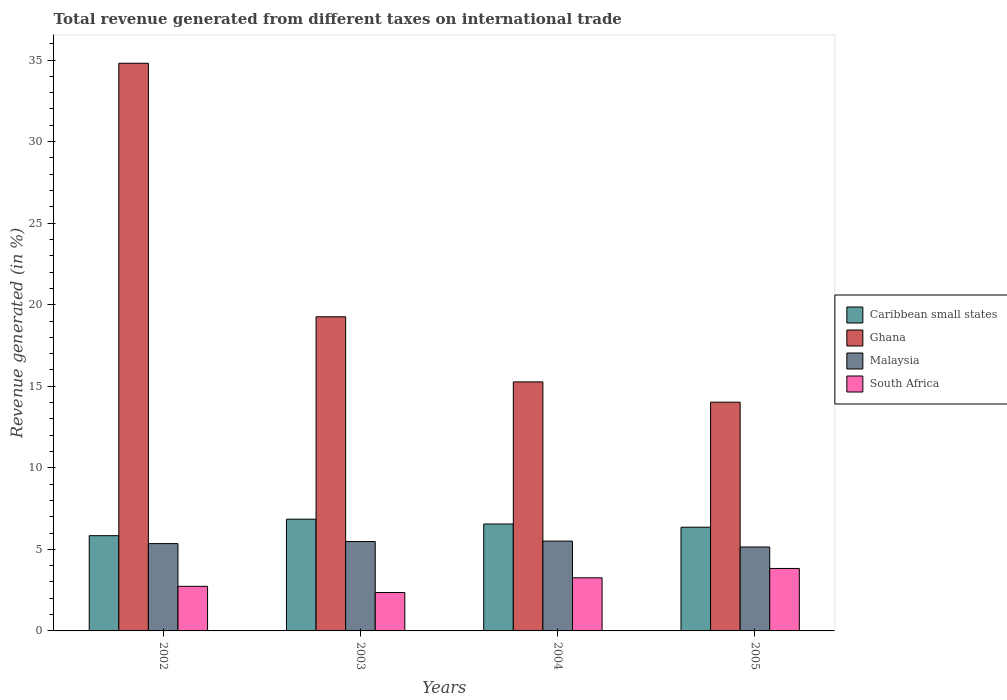Are the number of bars per tick equal to the number of legend labels?
Ensure brevity in your answer.  Yes. How many bars are there on the 1st tick from the right?
Offer a terse response. 4. What is the total revenue generated in Caribbean small states in 2003?
Give a very brief answer. 6.85. Across all years, what is the maximum total revenue generated in Caribbean small states?
Ensure brevity in your answer.  6.85. Across all years, what is the minimum total revenue generated in South Africa?
Offer a terse response. 2.36. In which year was the total revenue generated in South Africa minimum?
Offer a terse response. 2003. What is the total total revenue generated in Ghana in the graph?
Your answer should be very brief. 83.35. What is the difference between the total revenue generated in South Africa in 2002 and that in 2005?
Keep it short and to the point. -1.1. What is the difference between the total revenue generated in South Africa in 2005 and the total revenue generated in Malaysia in 2004?
Your answer should be compact. -1.68. What is the average total revenue generated in Ghana per year?
Give a very brief answer. 20.84. In the year 2005, what is the difference between the total revenue generated in Malaysia and total revenue generated in Ghana?
Your answer should be very brief. -8.88. What is the ratio of the total revenue generated in Ghana in 2004 to that in 2005?
Ensure brevity in your answer.  1.09. Is the total revenue generated in South Africa in 2003 less than that in 2004?
Keep it short and to the point. Yes. Is the difference between the total revenue generated in Malaysia in 2002 and 2003 greater than the difference between the total revenue generated in Ghana in 2002 and 2003?
Ensure brevity in your answer.  No. What is the difference between the highest and the second highest total revenue generated in South Africa?
Your response must be concise. 0.57. What is the difference between the highest and the lowest total revenue generated in Malaysia?
Give a very brief answer. 0.36. What does the 4th bar from the left in 2005 represents?
Your response must be concise. South Africa. What does the 3rd bar from the right in 2004 represents?
Ensure brevity in your answer.  Ghana. Is it the case that in every year, the sum of the total revenue generated in South Africa and total revenue generated in Caribbean small states is greater than the total revenue generated in Ghana?
Make the answer very short. No. What is the difference between two consecutive major ticks on the Y-axis?
Ensure brevity in your answer.  5. Does the graph contain any zero values?
Provide a succinct answer. No. Does the graph contain grids?
Provide a short and direct response. No. What is the title of the graph?
Your answer should be very brief. Total revenue generated from different taxes on international trade. What is the label or title of the X-axis?
Your answer should be very brief. Years. What is the label or title of the Y-axis?
Keep it short and to the point. Revenue generated (in %). What is the Revenue generated (in %) in Caribbean small states in 2002?
Provide a short and direct response. 5.84. What is the Revenue generated (in %) of Ghana in 2002?
Give a very brief answer. 34.8. What is the Revenue generated (in %) in Malaysia in 2002?
Make the answer very short. 5.35. What is the Revenue generated (in %) of South Africa in 2002?
Your answer should be compact. 2.73. What is the Revenue generated (in %) in Caribbean small states in 2003?
Your answer should be very brief. 6.85. What is the Revenue generated (in %) in Ghana in 2003?
Give a very brief answer. 19.26. What is the Revenue generated (in %) of Malaysia in 2003?
Provide a short and direct response. 5.48. What is the Revenue generated (in %) in South Africa in 2003?
Your response must be concise. 2.36. What is the Revenue generated (in %) of Caribbean small states in 2004?
Keep it short and to the point. 6.56. What is the Revenue generated (in %) in Ghana in 2004?
Give a very brief answer. 15.27. What is the Revenue generated (in %) in Malaysia in 2004?
Your answer should be very brief. 5.51. What is the Revenue generated (in %) in South Africa in 2004?
Your answer should be compact. 3.26. What is the Revenue generated (in %) in Caribbean small states in 2005?
Offer a terse response. 6.36. What is the Revenue generated (in %) in Ghana in 2005?
Provide a succinct answer. 14.02. What is the Revenue generated (in %) in Malaysia in 2005?
Keep it short and to the point. 5.15. What is the Revenue generated (in %) of South Africa in 2005?
Provide a succinct answer. 3.83. Across all years, what is the maximum Revenue generated (in %) in Caribbean small states?
Offer a very short reply. 6.85. Across all years, what is the maximum Revenue generated (in %) of Ghana?
Offer a terse response. 34.8. Across all years, what is the maximum Revenue generated (in %) in Malaysia?
Ensure brevity in your answer.  5.51. Across all years, what is the maximum Revenue generated (in %) in South Africa?
Give a very brief answer. 3.83. Across all years, what is the minimum Revenue generated (in %) in Caribbean small states?
Ensure brevity in your answer.  5.84. Across all years, what is the minimum Revenue generated (in %) of Ghana?
Offer a terse response. 14.02. Across all years, what is the minimum Revenue generated (in %) of Malaysia?
Your answer should be compact. 5.15. Across all years, what is the minimum Revenue generated (in %) in South Africa?
Ensure brevity in your answer.  2.36. What is the total Revenue generated (in %) in Caribbean small states in the graph?
Your answer should be compact. 25.6. What is the total Revenue generated (in %) in Ghana in the graph?
Your answer should be very brief. 83.35. What is the total Revenue generated (in %) of Malaysia in the graph?
Ensure brevity in your answer.  21.49. What is the total Revenue generated (in %) of South Africa in the graph?
Keep it short and to the point. 12.18. What is the difference between the Revenue generated (in %) of Caribbean small states in 2002 and that in 2003?
Give a very brief answer. -1.01. What is the difference between the Revenue generated (in %) of Ghana in 2002 and that in 2003?
Keep it short and to the point. 15.54. What is the difference between the Revenue generated (in %) of Malaysia in 2002 and that in 2003?
Keep it short and to the point. -0.13. What is the difference between the Revenue generated (in %) of South Africa in 2002 and that in 2003?
Your answer should be very brief. 0.38. What is the difference between the Revenue generated (in %) of Caribbean small states in 2002 and that in 2004?
Offer a terse response. -0.72. What is the difference between the Revenue generated (in %) in Ghana in 2002 and that in 2004?
Provide a short and direct response. 19.54. What is the difference between the Revenue generated (in %) of Malaysia in 2002 and that in 2004?
Offer a terse response. -0.15. What is the difference between the Revenue generated (in %) of South Africa in 2002 and that in 2004?
Your answer should be compact. -0.52. What is the difference between the Revenue generated (in %) in Caribbean small states in 2002 and that in 2005?
Give a very brief answer. -0.52. What is the difference between the Revenue generated (in %) of Ghana in 2002 and that in 2005?
Your response must be concise. 20.78. What is the difference between the Revenue generated (in %) of Malaysia in 2002 and that in 2005?
Offer a very short reply. 0.21. What is the difference between the Revenue generated (in %) of South Africa in 2002 and that in 2005?
Your response must be concise. -1.1. What is the difference between the Revenue generated (in %) of Caribbean small states in 2003 and that in 2004?
Give a very brief answer. 0.3. What is the difference between the Revenue generated (in %) of Ghana in 2003 and that in 2004?
Provide a short and direct response. 3.99. What is the difference between the Revenue generated (in %) of Malaysia in 2003 and that in 2004?
Your response must be concise. -0.03. What is the difference between the Revenue generated (in %) in South Africa in 2003 and that in 2004?
Your answer should be very brief. -0.9. What is the difference between the Revenue generated (in %) in Caribbean small states in 2003 and that in 2005?
Your response must be concise. 0.49. What is the difference between the Revenue generated (in %) in Ghana in 2003 and that in 2005?
Offer a terse response. 5.24. What is the difference between the Revenue generated (in %) of Malaysia in 2003 and that in 2005?
Ensure brevity in your answer.  0.33. What is the difference between the Revenue generated (in %) in South Africa in 2003 and that in 2005?
Provide a short and direct response. -1.47. What is the difference between the Revenue generated (in %) of Caribbean small states in 2004 and that in 2005?
Give a very brief answer. 0.2. What is the difference between the Revenue generated (in %) in Ghana in 2004 and that in 2005?
Provide a short and direct response. 1.24. What is the difference between the Revenue generated (in %) of Malaysia in 2004 and that in 2005?
Offer a very short reply. 0.36. What is the difference between the Revenue generated (in %) in South Africa in 2004 and that in 2005?
Ensure brevity in your answer.  -0.57. What is the difference between the Revenue generated (in %) of Caribbean small states in 2002 and the Revenue generated (in %) of Ghana in 2003?
Give a very brief answer. -13.42. What is the difference between the Revenue generated (in %) of Caribbean small states in 2002 and the Revenue generated (in %) of Malaysia in 2003?
Give a very brief answer. 0.36. What is the difference between the Revenue generated (in %) in Caribbean small states in 2002 and the Revenue generated (in %) in South Africa in 2003?
Keep it short and to the point. 3.48. What is the difference between the Revenue generated (in %) of Ghana in 2002 and the Revenue generated (in %) of Malaysia in 2003?
Provide a succinct answer. 29.32. What is the difference between the Revenue generated (in %) in Ghana in 2002 and the Revenue generated (in %) in South Africa in 2003?
Offer a terse response. 32.45. What is the difference between the Revenue generated (in %) of Malaysia in 2002 and the Revenue generated (in %) of South Africa in 2003?
Provide a short and direct response. 3. What is the difference between the Revenue generated (in %) of Caribbean small states in 2002 and the Revenue generated (in %) of Ghana in 2004?
Offer a terse response. -9.43. What is the difference between the Revenue generated (in %) in Caribbean small states in 2002 and the Revenue generated (in %) in Malaysia in 2004?
Your response must be concise. 0.33. What is the difference between the Revenue generated (in %) of Caribbean small states in 2002 and the Revenue generated (in %) of South Africa in 2004?
Offer a terse response. 2.58. What is the difference between the Revenue generated (in %) in Ghana in 2002 and the Revenue generated (in %) in Malaysia in 2004?
Provide a succinct answer. 29.3. What is the difference between the Revenue generated (in %) of Ghana in 2002 and the Revenue generated (in %) of South Africa in 2004?
Provide a short and direct response. 31.55. What is the difference between the Revenue generated (in %) in Malaysia in 2002 and the Revenue generated (in %) in South Africa in 2004?
Offer a terse response. 2.1. What is the difference between the Revenue generated (in %) in Caribbean small states in 2002 and the Revenue generated (in %) in Ghana in 2005?
Your answer should be very brief. -8.19. What is the difference between the Revenue generated (in %) in Caribbean small states in 2002 and the Revenue generated (in %) in Malaysia in 2005?
Your answer should be very brief. 0.69. What is the difference between the Revenue generated (in %) of Caribbean small states in 2002 and the Revenue generated (in %) of South Africa in 2005?
Offer a very short reply. 2.01. What is the difference between the Revenue generated (in %) in Ghana in 2002 and the Revenue generated (in %) in Malaysia in 2005?
Your answer should be very brief. 29.66. What is the difference between the Revenue generated (in %) in Ghana in 2002 and the Revenue generated (in %) in South Africa in 2005?
Give a very brief answer. 30.97. What is the difference between the Revenue generated (in %) in Malaysia in 2002 and the Revenue generated (in %) in South Africa in 2005?
Provide a short and direct response. 1.52. What is the difference between the Revenue generated (in %) in Caribbean small states in 2003 and the Revenue generated (in %) in Ghana in 2004?
Make the answer very short. -8.42. What is the difference between the Revenue generated (in %) of Caribbean small states in 2003 and the Revenue generated (in %) of Malaysia in 2004?
Keep it short and to the point. 1.34. What is the difference between the Revenue generated (in %) of Caribbean small states in 2003 and the Revenue generated (in %) of South Africa in 2004?
Your answer should be very brief. 3.59. What is the difference between the Revenue generated (in %) in Ghana in 2003 and the Revenue generated (in %) in Malaysia in 2004?
Provide a succinct answer. 13.75. What is the difference between the Revenue generated (in %) in Ghana in 2003 and the Revenue generated (in %) in South Africa in 2004?
Keep it short and to the point. 16. What is the difference between the Revenue generated (in %) of Malaysia in 2003 and the Revenue generated (in %) of South Africa in 2004?
Give a very brief answer. 2.22. What is the difference between the Revenue generated (in %) in Caribbean small states in 2003 and the Revenue generated (in %) in Ghana in 2005?
Your answer should be compact. -7.17. What is the difference between the Revenue generated (in %) of Caribbean small states in 2003 and the Revenue generated (in %) of Malaysia in 2005?
Provide a succinct answer. 1.71. What is the difference between the Revenue generated (in %) in Caribbean small states in 2003 and the Revenue generated (in %) in South Africa in 2005?
Your response must be concise. 3.02. What is the difference between the Revenue generated (in %) in Ghana in 2003 and the Revenue generated (in %) in Malaysia in 2005?
Provide a succinct answer. 14.11. What is the difference between the Revenue generated (in %) of Ghana in 2003 and the Revenue generated (in %) of South Africa in 2005?
Give a very brief answer. 15.43. What is the difference between the Revenue generated (in %) in Malaysia in 2003 and the Revenue generated (in %) in South Africa in 2005?
Ensure brevity in your answer.  1.65. What is the difference between the Revenue generated (in %) in Caribbean small states in 2004 and the Revenue generated (in %) in Ghana in 2005?
Your answer should be very brief. -7.47. What is the difference between the Revenue generated (in %) in Caribbean small states in 2004 and the Revenue generated (in %) in Malaysia in 2005?
Provide a short and direct response. 1.41. What is the difference between the Revenue generated (in %) in Caribbean small states in 2004 and the Revenue generated (in %) in South Africa in 2005?
Provide a short and direct response. 2.73. What is the difference between the Revenue generated (in %) of Ghana in 2004 and the Revenue generated (in %) of Malaysia in 2005?
Make the answer very short. 10.12. What is the difference between the Revenue generated (in %) of Ghana in 2004 and the Revenue generated (in %) of South Africa in 2005?
Your answer should be compact. 11.44. What is the difference between the Revenue generated (in %) in Malaysia in 2004 and the Revenue generated (in %) in South Africa in 2005?
Offer a very short reply. 1.68. What is the average Revenue generated (in %) in Caribbean small states per year?
Ensure brevity in your answer.  6.4. What is the average Revenue generated (in %) of Ghana per year?
Give a very brief answer. 20.84. What is the average Revenue generated (in %) in Malaysia per year?
Offer a terse response. 5.37. What is the average Revenue generated (in %) in South Africa per year?
Your answer should be very brief. 3.04. In the year 2002, what is the difference between the Revenue generated (in %) of Caribbean small states and Revenue generated (in %) of Ghana?
Keep it short and to the point. -28.96. In the year 2002, what is the difference between the Revenue generated (in %) in Caribbean small states and Revenue generated (in %) in Malaysia?
Offer a very short reply. 0.49. In the year 2002, what is the difference between the Revenue generated (in %) of Caribbean small states and Revenue generated (in %) of South Africa?
Offer a terse response. 3.11. In the year 2002, what is the difference between the Revenue generated (in %) in Ghana and Revenue generated (in %) in Malaysia?
Give a very brief answer. 29.45. In the year 2002, what is the difference between the Revenue generated (in %) in Ghana and Revenue generated (in %) in South Africa?
Offer a terse response. 32.07. In the year 2002, what is the difference between the Revenue generated (in %) of Malaysia and Revenue generated (in %) of South Africa?
Offer a terse response. 2.62. In the year 2003, what is the difference between the Revenue generated (in %) of Caribbean small states and Revenue generated (in %) of Ghana?
Ensure brevity in your answer.  -12.41. In the year 2003, what is the difference between the Revenue generated (in %) in Caribbean small states and Revenue generated (in %) in Malaysia?
Provide a short and direct response. 1.37. In the year 2003, what is the difference between the Revenue generated (in %) of Caribbean small states and Revenue generated (in %) of South Africa?
Offer a very short reply. 4.49. In the year 2003, what is the difference between the Revenue generated (in %) of Ghana and Revenue generated (in %) of Malaysia?
Provide a succinct answer. 13.78. In the year 2003, what is the difference between the Revenue generated (in %) of Ghana and Revenue generated (in %) of South Africa?
Ensure brevity in your answer.  16.9. In the year 2003, what is the difference between the Revenue generated (in %) in Malaysia and Revenue generated (in %) in South Africa?
Make the answer very short. 3.12. In the year 2004, what is the difference between the Revenue generated (in %) of Caribbean small states and Revenue generated (in %) of Ghana?
Make the answer very short. -8.71. In the year 2004, what is the difference between the Revenue generated (in %) of Caribbean small states and Revenue generated (in %) of Malaysia?
Your answer should be compact. 1.05. In the year 2004, what is the difference between the Revenue generated (in %) of Caribbean small states and Revenue generated (in %) of South Africa?
Your answer should be very brief. 3.3. In the year 2004, what is the difference between the Revenue generated (in %) of Ghana and Revenue generated (in %) of Malaysia?
Make the answer very short. 9.76. In the year 2004, what is the difference between the Revenue generated (in %) of Ghana and Revenue generated (in %) of South Africa?
Your answer should be compact. 12.01. In the year 2004, what is the difference between the Revenue generated (in %) of Malaysia and Revenue generated (in %) of South Africa?
Your answer should be very brief. 2.25. In the year 2005, what is the difference between the Revenue generated (in %) of Caribbean small states and Revenue generated (in %) of Ghana?
Offer a very short reply. -7.67. In the year 2005, what is the difference between the Revenue generated (in %) in Caribbean small states and Revenue generated (in %) in Malaysia?
Your answer should be compact. 1.21. In the year 2005, what is the difference between the Revenue generated (in %) of Caribbean small states and Revenue generated (in %) of South Africa?
Your response must be concise. 2.53. In the year 2005, what is the difference between the Revenue generated (in %) in Ghana and Revenue generated (in %) in Malaysia?
Provide a short and direct response. 8.88. In the year 2005, what is the difference between the Revenue generated (in %) in Ghana and Revenue generated (in %) in South Africa?
Provide a short and direct response. 10.19. In the year 2005, what is the difference between the Revenue generated (in %) of Malaysia and Revenue generated (in %) of South Africa?
Provide a succinct answer. 1.32. What is the ratio of the Revenue generated (in %) of Caribbean small states in 2002 to that in 2003?
Your answer should be very brief. 0.85. What is the ratio of the Revenue generated (in %) of Ghana in 2002 to that in 2003?
Provide a short and direct response. 1.81. What is the ratio of the Revenue generated (in %) of Malaysia in 2002 to that in 2003?
Keep it short and to the point. 0.98. What is the ratio of the Revenue generated (in %) of South Africa in 2002 to that in 2003?
Your answer should be compact. 1.16. What is the ratio of the Revenue generated (in %) in Caribbean small states in 2002 to that in 2004?
Keep it short and to the point. 0.89. What is the ratio of the Revenue generated (in %) in Ghana in 2002 to that in 2004?
Keep it short and to the point. 2.28. What is the ratio of the Revenue generated (in %) of Malaysia in 2002 to that in 2004?
Keep it short and to the point. 0.97. What is the ratio of the Revenue generated (in %) of South Africa in 2002 to that in 2004?
Provide a short and direct response. 0.84. What is the ratio of the Revenue generated (in %) in Caribbean small states in 2002 to that in 2005?
Make the answer very short. 0.92. What is the ratio of the Revenue generated (in %) in Ghana in 2002 to that in 2005?
Offer a terse response. 2.48. What is the ratio of the Revenue generated (in %) in Malaysia in 2002 to that in 2005?
Keep it short and to the point. 1.04. What is the ratio of the Revenue generated (in %) in South Africa in 2002 to that in 2005?
Ensure brevity in your answer.  0.71. What is the ratio of the Revenue generated (in %) of Caribbean small states in 2003 to that in 2004?
Offer a terse response. 1.04. What is the ratio of the Revenue generated (in %) in Ghana in 2003 to that in 2004?
Ensure brevity in your answer.  1.26. What is the ratio of the Revenue generated (in %) in South Africa in 2003 to that in 2004?
Offer a terse response. 0.72. What is the ratio of the Revenue generated (in %) in Caribbean small states in 2003 to that in 2005?
Offer a very short reply. 1.08. What is the ratio of the Revenue generated (in %) in Ghana in 2003 to that in 2005?
Give a very brief answer. 1.37. What is the ratio of the Revenue generated (in %) of Malaysia in 2003 to that in 2005?
Your response must be concise. 1.06. What is the ratio of the Revenue generated (in %) of South Africa in 2003 to that in 2005?
Provide a short and direct response. 0.62. What is the ratio of the Revenue generated (in %) in Caribbean small states in 2004 to that in 2005?
Make the answer very short. 1.03. What is the ratio of the Revenue generated (in %) in Ghana in 2004 to that in 2005?
Keep it short and to the point. 1.09. What is the ratio of the Revenue generated (in %) in Malaysia in 2004 to that in 2005?
Your answer should be compact. 1.07. What is the ratio of the Revenue generated (in %) of South Africa in 2004 to that in 2005?
Keep it short and to the point. 0.85. What is the difference between the highest and the second highest Revenue generated (in %) of Caribbean small states?
Ensure brevity in your answer.  0.3. What is the difference between the highest and the second highest Revenue generated (in %) in Ghana?
Provide a succinct answer. 15.54. What is the difference between the highest and the second highest Revenue generated (in %) of Malaysia?
Offer a terse response. 0.03. What is the difference between the highest and the second highest Revenue generated (in %) of South Africa?
Keep it short and to the point. 0.57. What is the difference between the highest and the lowest Revenue generated (in %) of Caribbean small states?
Make the answer very short. 1.01. What is the difference between the highest and the lowest Revenue generated (in %) of Ghana?
Your answer should be very brief. 20.78. What is the difference between the highest and the lowest Revenue generated (in %) in Malaysia?
Give a very brief answer. 0.36. What is the difference between the highest and the lowest Revenue generated (in %) in South Africa?
Offer a very short reply. 1.47. 